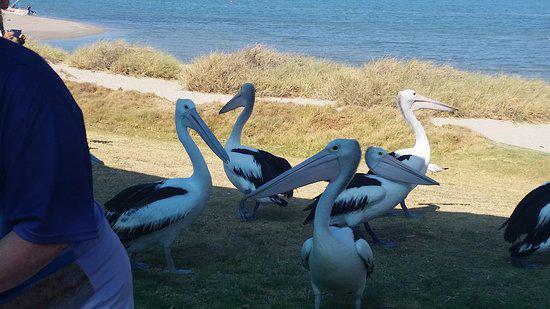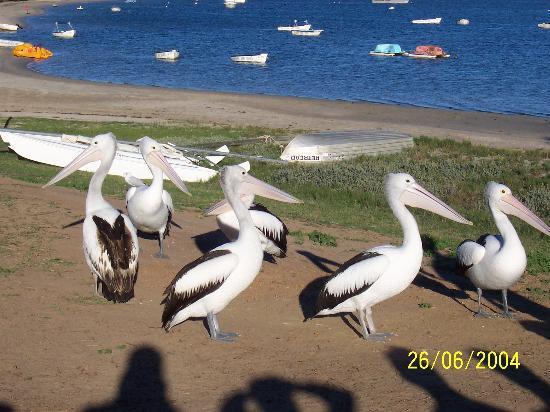The first image is the image on the left, the second image is the image on the right. Assess this claim about the two images: "There is a single human feeding a pelican with white and black feathers.". Correct or not? Answer yes or no. No. The first image is the image on the left, the second image is the image on the right. Evaluate the accuracy of this statement regarding the images: "There is no more than one bird on a beach in the left image.". Is it true? Answer yes or no. No. 